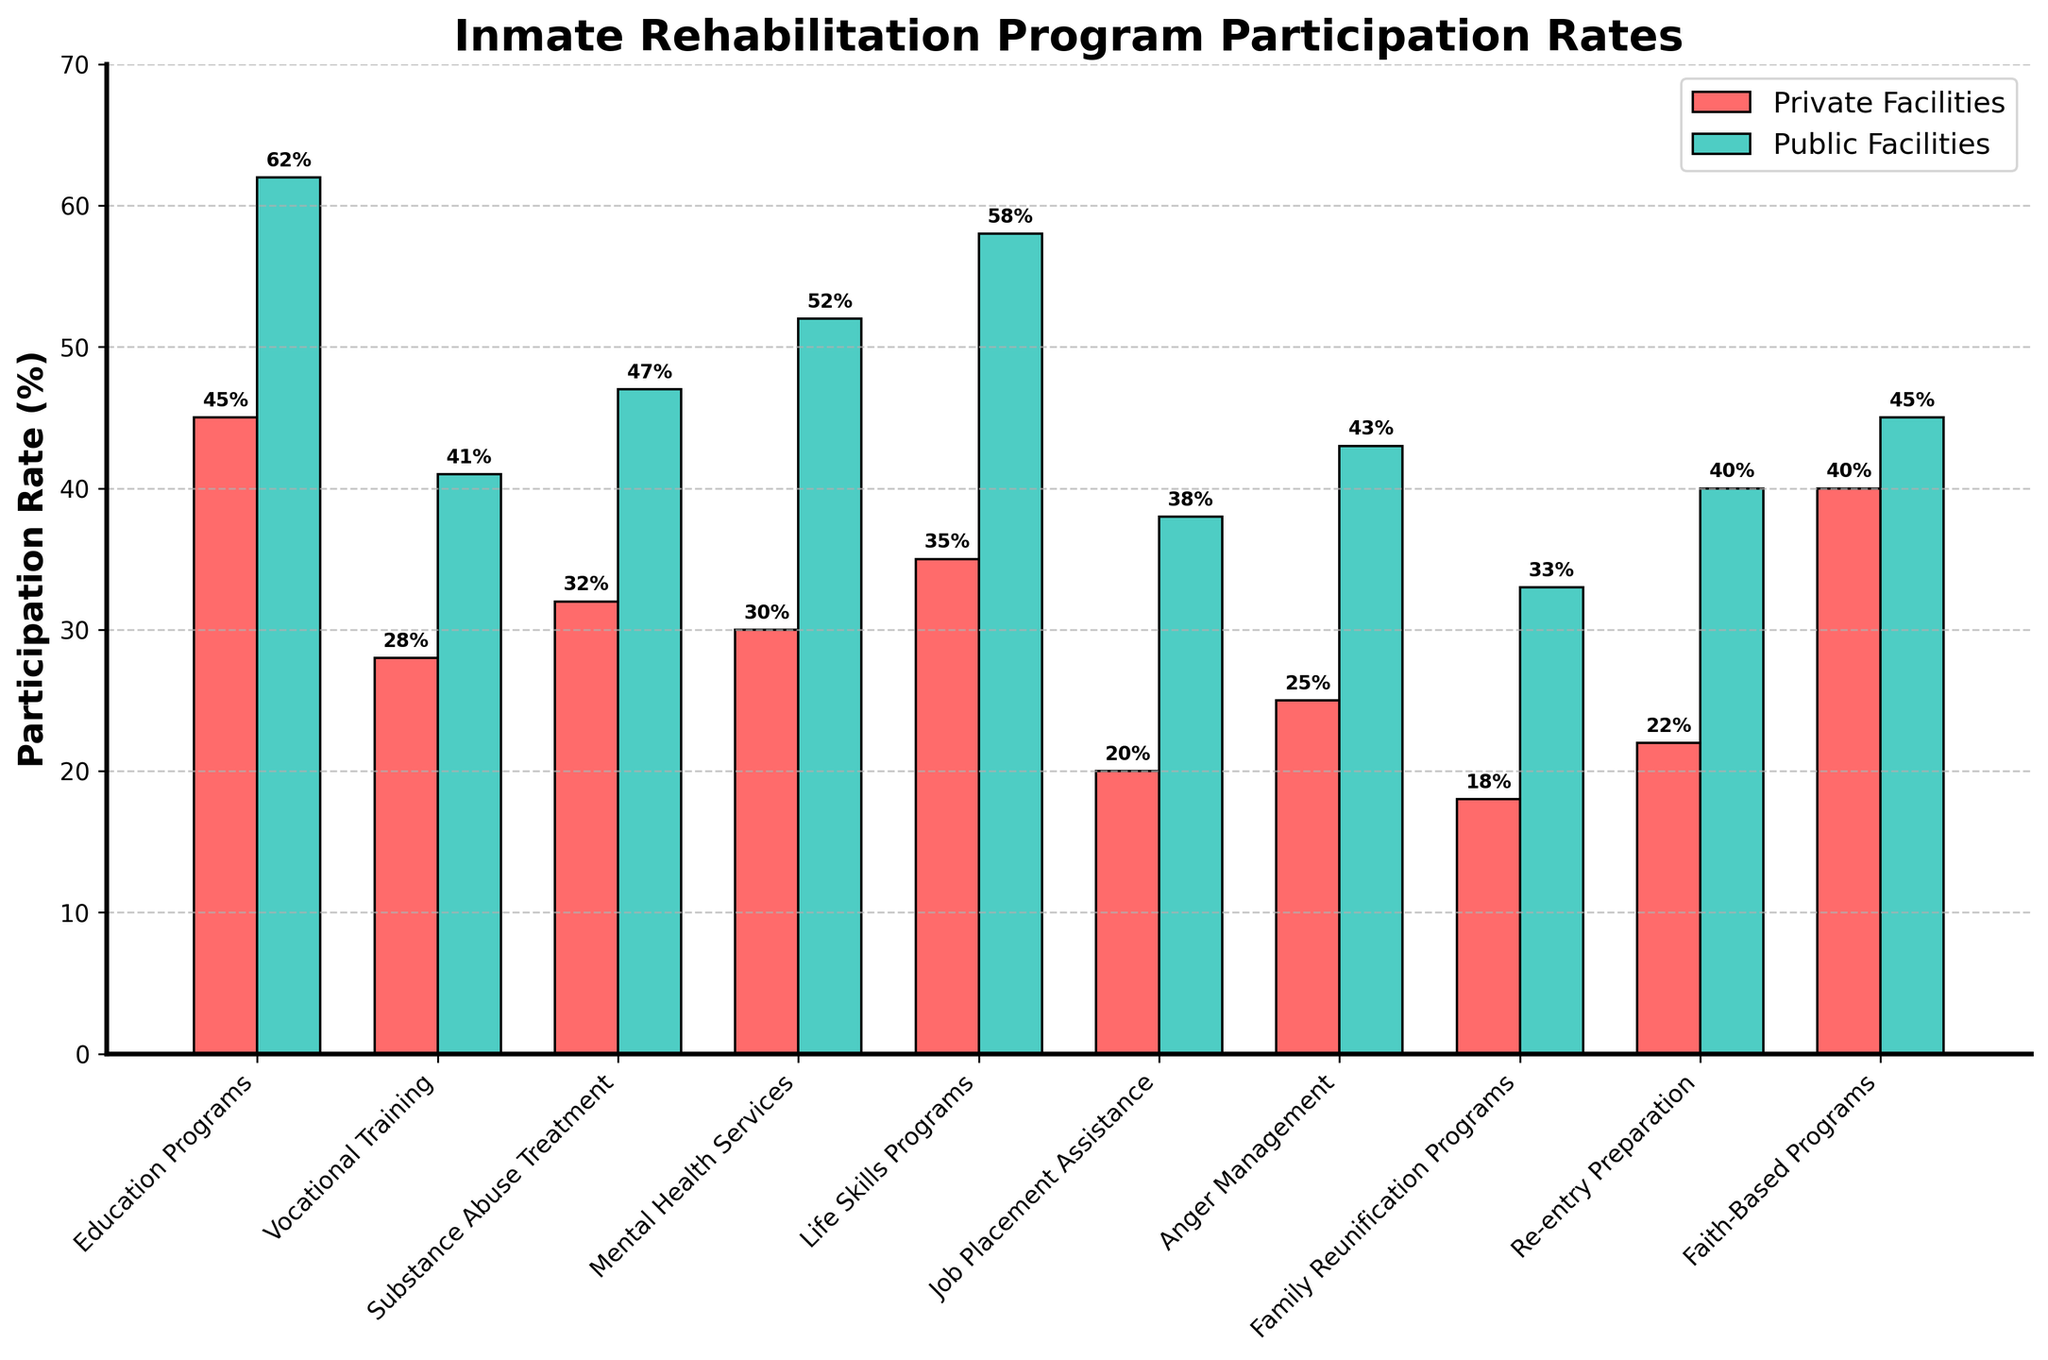Which facility type has a higher participation rate in Education Programs? Compare the height of the bars representing Education Programs on the bar chart. The bar for Public Facilities is higher than the bar for Private Facilities.
Answer: Public Facilities How much higher is the participation rate in Mental Health Services at Public Facilities compared to Private Facilities? Subtract the participation rate in Private Facilities from the rate in Public Facilities for Mental Health Services: 52% - 30% = 22%.
Answer: 22% Which program has the smallest difference in participation rates between Private and Public Facilities? Compare the differences between the heights of the bars for each program. The smallest difference is for Faith-Based Programs, where the difference is 5% (45% - 40%).
Answer: Faith-Based Programs What is the average participation rate for Substance Abuse Treatment in both Private and Public Facilities? Calculate the average participation rate by summing the values for Private and Public Facilities and dividing by 2: (32% + 47%) / 2 = 39.5%.
Answer: 39.5% If we were to prioritize increasing participation rates in programs with the largest gaps, which two programs should be targeted first? Identify the programs with the largest differences between the participation rates in Private and Public Facilities. The top two are Mental Health Services (22% difference) and Life Skills Programs (23% difference).
Answer: Mental Health Services and Life Skills Programs Which program has the second highest participation rate in Private Facilities? Rank the programs based on their participation rates in Private Facilities. The second highest is Education Programs at 45%.
Answer: Education Programs How many programs in Public Facilities have participation rates over 50%? Count the number of bars in Public Facilities that exceed the 50% mark. There are three: Education Programs, Mental Health Services, and Life Skills Programs.
Answer: 3 Which facility type has higher participation rates in Job Placement Assistance and Family Reunification Programs? Compare the heights of the bars for both programs. Public Facilities have higher participation rates in both Job Placement Assistance (38% vs. 20%) and Family Reunification Programs (33% vs. 18%).
Answer: Public Facilities What is the total participation rate of all programs combined in Private Facilities? Sum the participation rates of all programs in Private Facilities: 45% + 28% + 32% + 30% + 35% + 20% + 25% + 18% + 22% + 40% = 295%.
Answer: 295% Which program shows the smallest disparity in participation rates between Private and Public Facilities in favor of Public Facilities? Find the program where the Public Facilities' rate barely surpasses the Private Facilities' rate. This is Faith-Based Programs with a difference of 5%.
Answer: Faith-Based Programs 